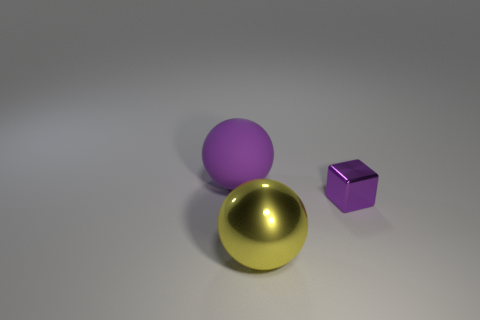Add 3 shiny spheres. How many objects exist? 6 Subtract all spheres. How many objects are left? 1 Subtract 2 balls. How many balls are left? 0 Subtract all yellow blocks. Subtract all blue spheres. How many blocks are left? 1 Subtract all tiny purple cubes. Subtract all green rubber balls. How many objects are left? 2 Add 2 large spheres. How many large spheres are left? 4 Add 1 tiny purple metallic blocks. How many tiny purple metallic blocks exist? 2 Subtract 0 green cylinders. How many objects are left? 3 